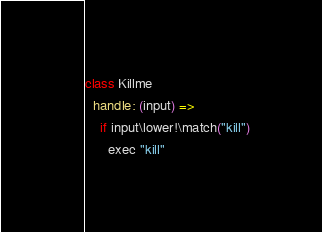<code> <loc_0><loc_0><loc_500><loc_500><_MoonScript_>
class Killme
  handle: (input) =>
    if input\lower!\match("kill")
      exec "kill"
</code> 